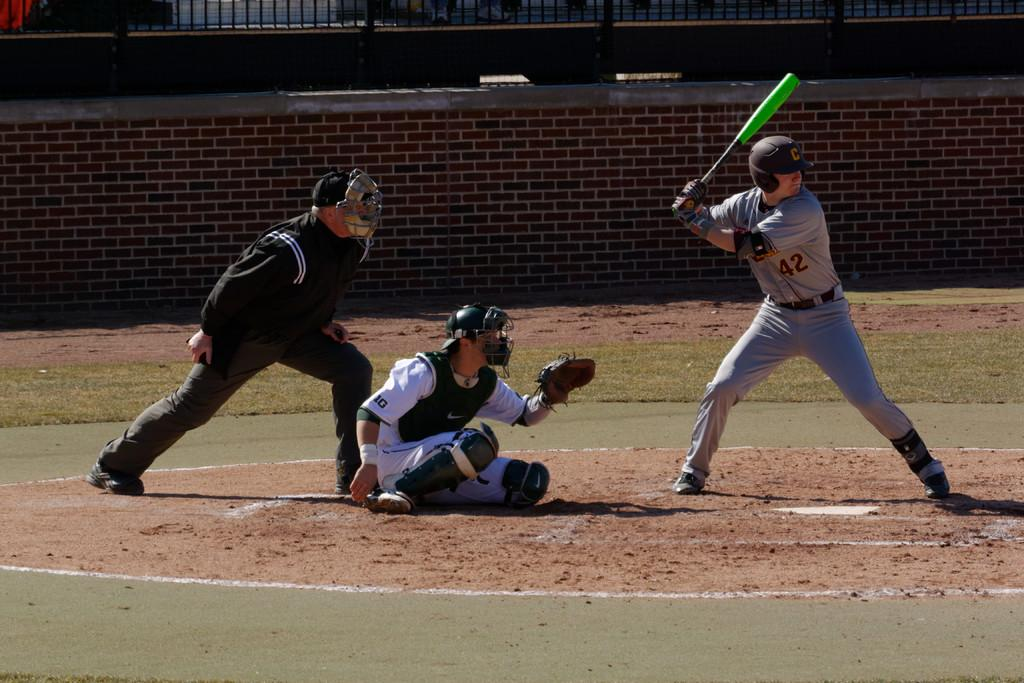<image>
Relay a brief, clear account of the picture shown. a batter getting ready to hit with a C on their helmet 